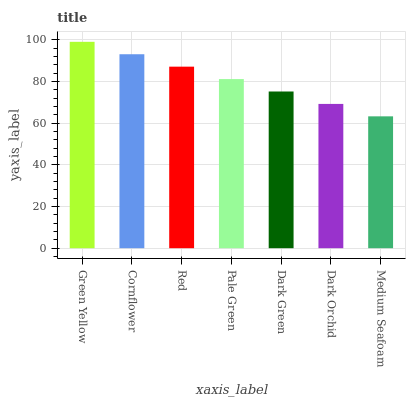Is Medium Seafoam the minimum?
Answer yes or no. Yes. Is Green Yellow the maximum?
Answer yes or no. Yes. Is Cornflower the minimum?
Answer yes or no. No. Is Cornflower the maximum?
Answer yes or no. No. Is Green Yellow greater than Cornflower?
Answer yes or no. Yes. Is Cornflower less than Green Yellow?
Answer yes or no. Yes. Is Cornflower greater than Green Yellow?
Answer yes or no. No. Is Green Yellow less than Cornflower?
Answer yes or no. No. Is Pale Green the high median?
Answer yes or no. Yes. Is Pale Green the low median?
Answer yes or no. Yes. Is Cornflower the high median?
Answer yes or no. No. Is Medium Seafoam the low median?
Answer yes or no. No. 